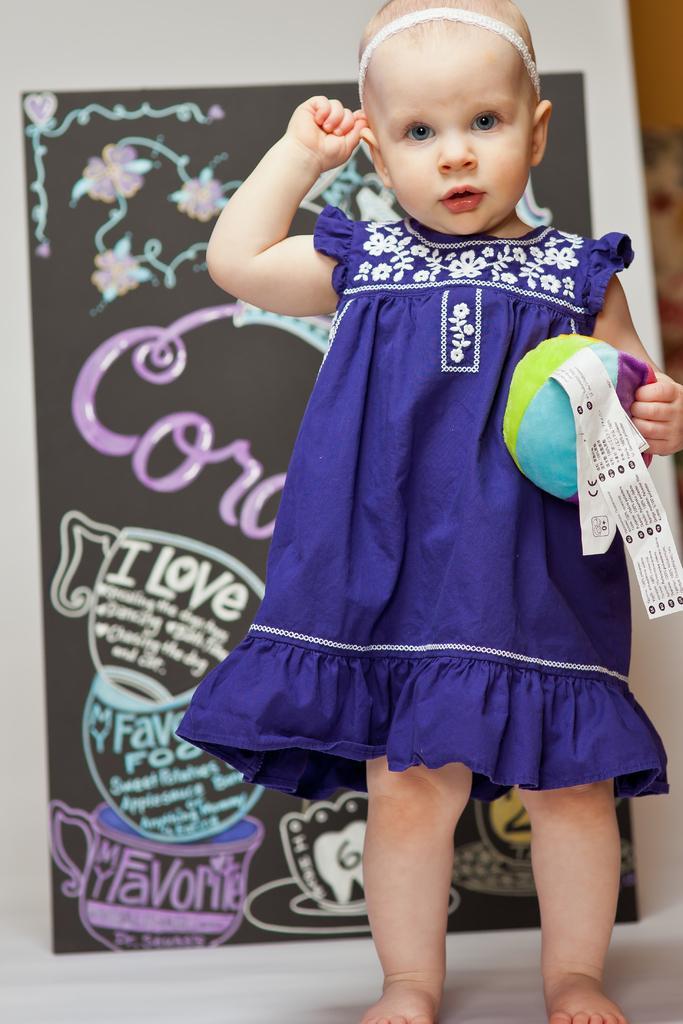Could you give a brief overview of what you see in this image? In this image, we can see a kid holding some object. We can see the ground. We can see the background with the poster. 